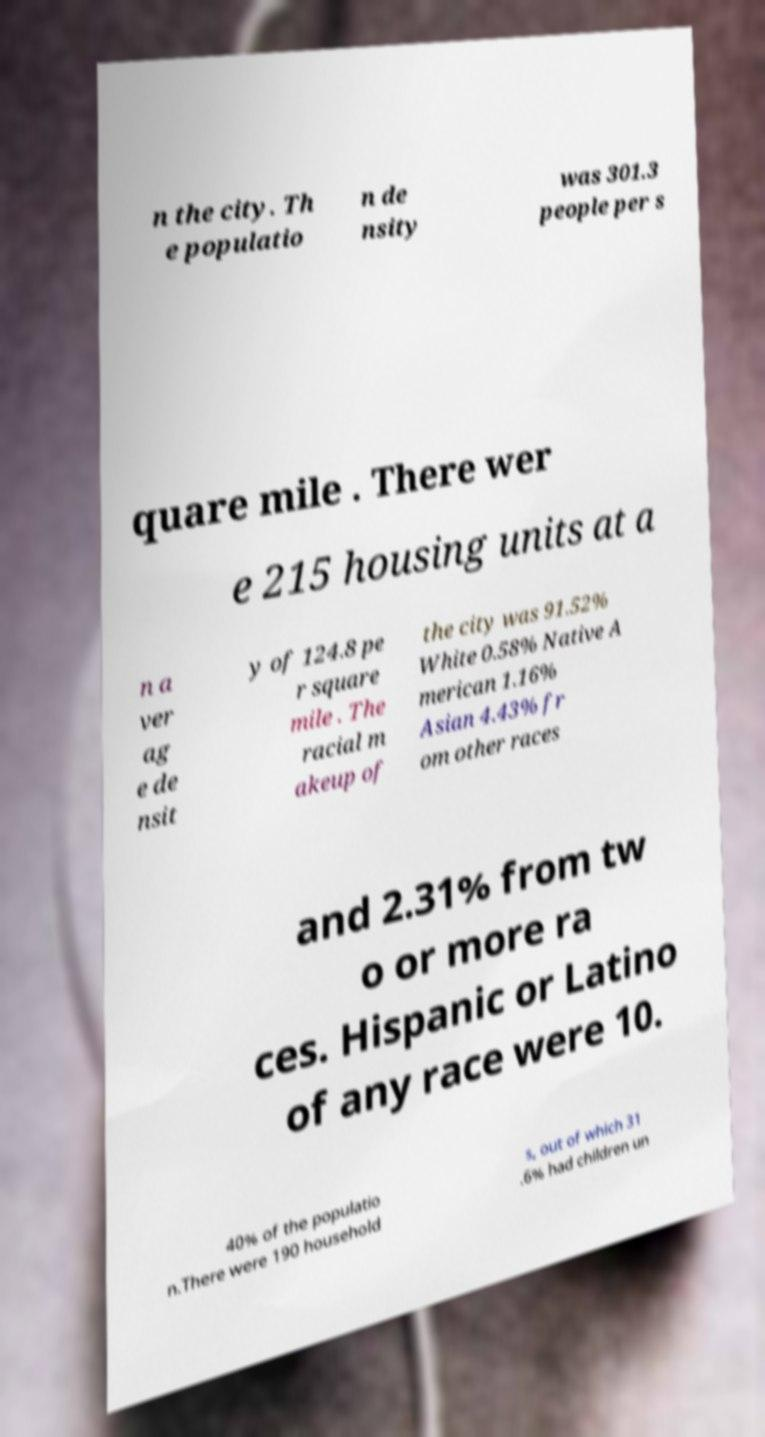Can you accurately transcribe the text from the provided image for me? n the city. Th e populatio n de nsity was 301.3 people per s quare mile . There wer e 215 housing units at a n a ver ag e de nsit y of 124.8 pe r square mile . The racial m akeup of the city was 91.52% White 0.58% Native A merican 1.16% Asian 4.43% fr om other races and 2.31% from tw o or more ra ces. Hispanic or Latino of any race were 10. 40% of the populatio n.There were 190 household s, out of which 31 .6% had children un 